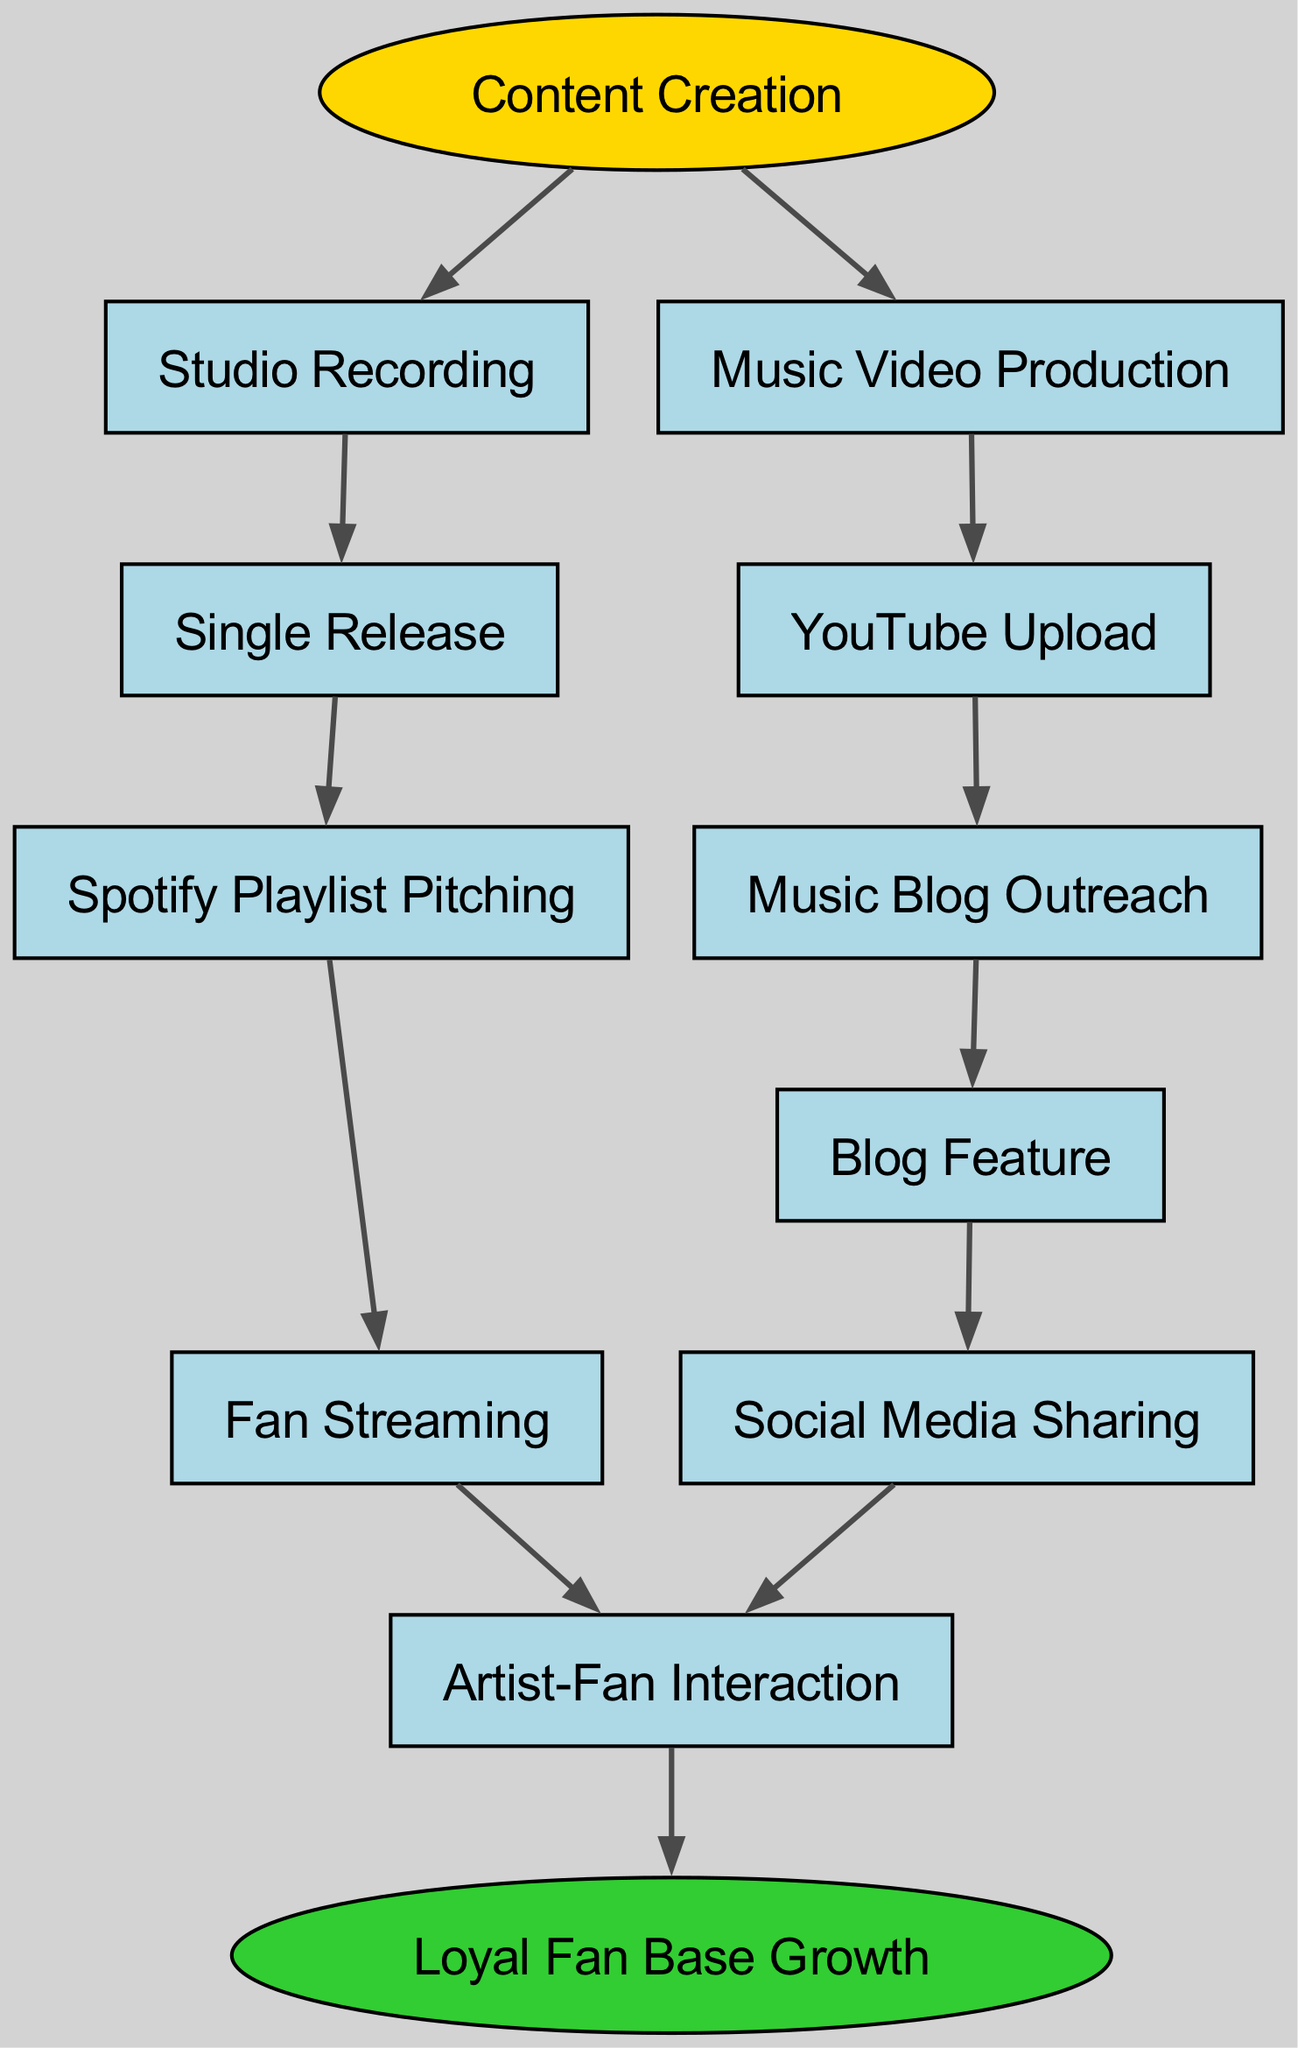What is the starting point of the food chain? The starting point of the food chain is "Content Creation". It is the first element listed in the diagram that leads to other activities in the promotion process.
Answer: Content Creation How many nodes are in the diagram? To find the total number of nodes, we count each unique element listed, including both parent nodes and their children. The count results in 11 distinct elements.
Answer: 11 What follows after "Single Release"? The diagram shows that "Single Release" leads directly to "Spotify Playlist Pitching", making it the next step in the progression.
Answer: Spotify Playlist Pitching Which node is specifically responsible for releasing a music video? The node that focuses on releasing a music video is "Music Video Production". It is clearly identifiable as a child under the main element "Content Creation".
Answer: Music Video Production What is the final outcome of the food chain? The final outcome of the food chain is "Loyal Fan Base Growth", which is identified as the end of the process after several interactions with fans.
Answer: Loyal Fan Base Growth What two nodes lead to "Artist-Fan Interaction"? The diagram indicates that "Fan Streaming" and "Social Media Sharing" both lead to "Artist-Fan Interaction", showing multiple pathways to engage with fans.
Answer: Fan Streaming, Social Media Sharing How does "Music Blog Outreach" connect to subsequent activities? After "Music Blog Outreach", the flow goes to "Blog Feature", which further leads to "Social Media Sharing". This illustrates the sequential steps of promoting through blogs.
Answer: Blog Feature What is the relationship between "YouTube Upload" and "Social Media Sharing"? "YouTube Upload" does not directly connect to "Social Media Sharing"; instead, it connects to "Music Blog Outreach", which eventually leads to "Blog Feature" followed by "Social Media Sharing". This reflects an indirect relationship.
Answer: Indirect Which node represents the activity of streaming music by fans? The node that represents the activity of streaming music by fans is "Fan Streaming". This indicates the essential role of fans in promoting the artist's music on platforms.
Answer: Fan Streaming 